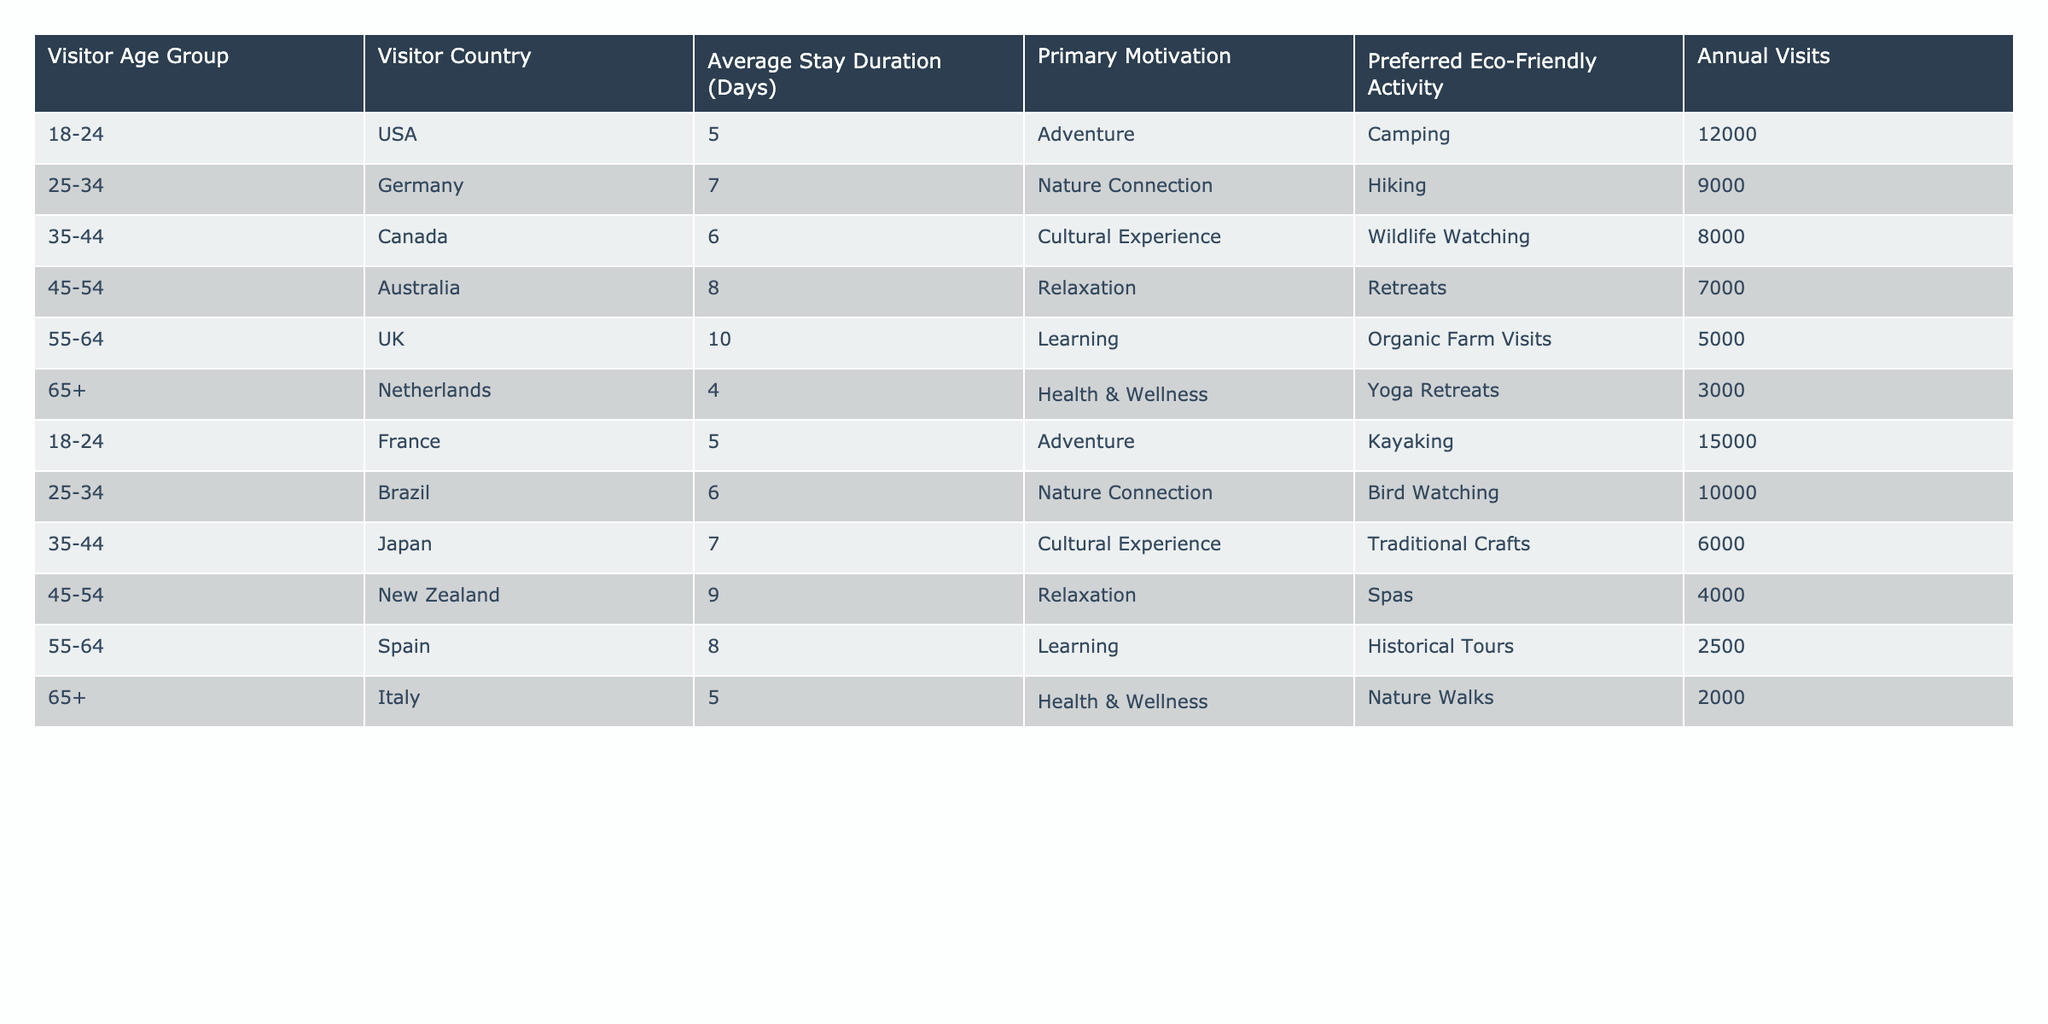What is the primary motivation for visitors from Australia? The table shows that visitors from Australia have the primary motivation of Relaxation.
Answer: Relaxation How many annual visits are attributed to visitors aged 25-34 from Brazil? According to the table, the annual visits for the 25-34 age group from Brazil is 10,000.
Answer: 10,000 What is the average stay duration for visitors from the UK? From the table, the average stay duration for visitors from the UK is 10 days.
Answer: 10 days Do visitors aged 65 and above prefer Yoga Retreats over Nature Walks? The table indicates that visitors aged 65 and above in the Netherlands chose Yoga Retreats, while those in Italy preferred Nature Walks; thus, the preference is situational rather than blanket.
Answer: Yes What is the total number of annual visits from visitors aged 18-24 across all countries? By summing the annual visits for the 18-24 age group: USA (12,000) + France (15,000) equals 27,000.
Answer: 27,000 Which age group has the highest average stay duration, and how long is it? Analyzing the stay duration, the 55-64 age group from the UK has the highest at 10 days.
Answer: 55-64 age group, 10 days Is the primary motivation for visitors from Canada cultural experience? The table states that the primary motivation for visitors from Canada is Cultural Experience, thus the answer is confirmed.
Answer: Yes Which eco-friendly activity is most preferred by visitors aged 35-44 from Canada? The data reveals that visitors from Canada aged 35-44 prefer Wildlife Watching as their eco-friendly activity.
Answer: Wildlife Watching What is the difference in average stay duration between visitors from Germany and visitors from Australia? The average stay for visitors from Germany is 7 days, while from Australia it is 8 days. The difference is 1 day (8 - 7).
Answer: 1 day Which country has the lowest annual visits and what is the number? The table records the annual visits for Italy (65+ age group) as 2,000, making it the lowest.
Answer: 2,000 